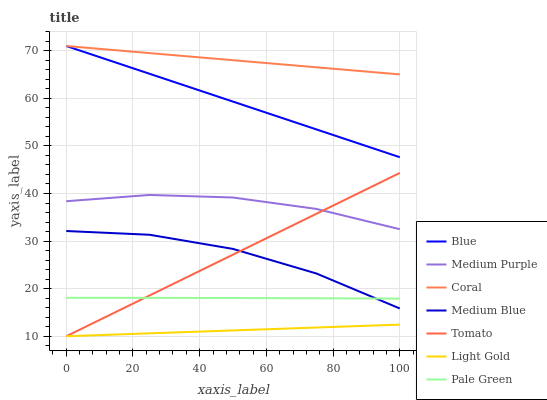Does Light Gold have the minimum area under the curve?
Answer yes or no. Yes. Does Coral have the maximum area under the curve?
Answer yes or no. Yes. Does Tomato have the minimum area under the curve?
Answer yes or no. No. Does Tomato have the maximum area under the curve?
Answer yes or no. No. Is Tomato the smoothest?
Answer yes or no. Yes. Is Medium Blue the roughest?
Answer yes or no. Yes. Is Coral the smoothest?
Answer yes or no. No. Is Coral the roughest?
Answer yes or no. No. Does Tomato have the lowest value?
Answer yes or no. Yes. Does Coral have the lowest value?
Answer yes or no. No. Does Coral have the highest value?
Answer yes or no. Yes. Does Tomato have the highest value?
Answer yes or no. No. Is Medium Blue less than Blue?
Answer yes or no. Yes. Is Blue greater than Medium Blue?
Answer yes or no. Yes. Does Medium Blue intersect Pale Green?
Answer yes or no. Yes. Is Medium Blue less than Pale Green?
Answer yes or no. No. Is Medium Blue greater than Pale Green?
Answer yes or no. No. Does Medium Blue intersect Blue?
Answer yes or no. No. 